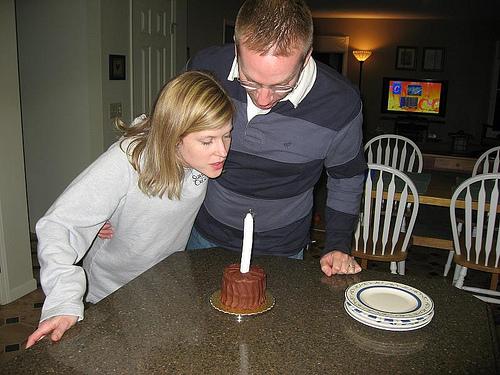What are these people making?
Be succinct. Nothing. Is the person blowing out a candle?
Answer briefly. Yes. Is the candle burning?
Concise answer only. No. Is the candle taller than the cake?
Keep it brief. Yes. How many people are in the image?
Keep it brief. 2. 